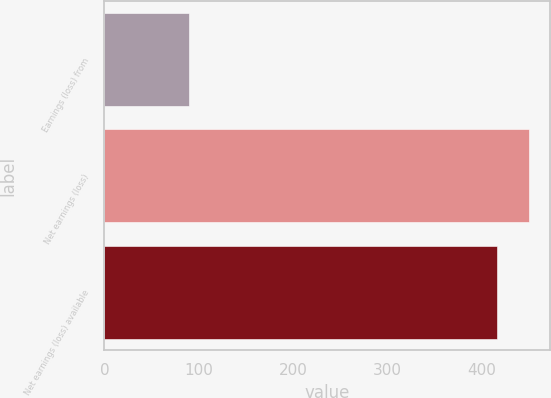<chart> <loc_0><loc_0><loc_500><loc_500><bar_chart><fcel>Earnings (loss) from<fcel>Net earnings (loss)<fcel>Net earnings (loss) available<nl><fcel>90<fcel>449.6<fcel>416<nl></chart> 